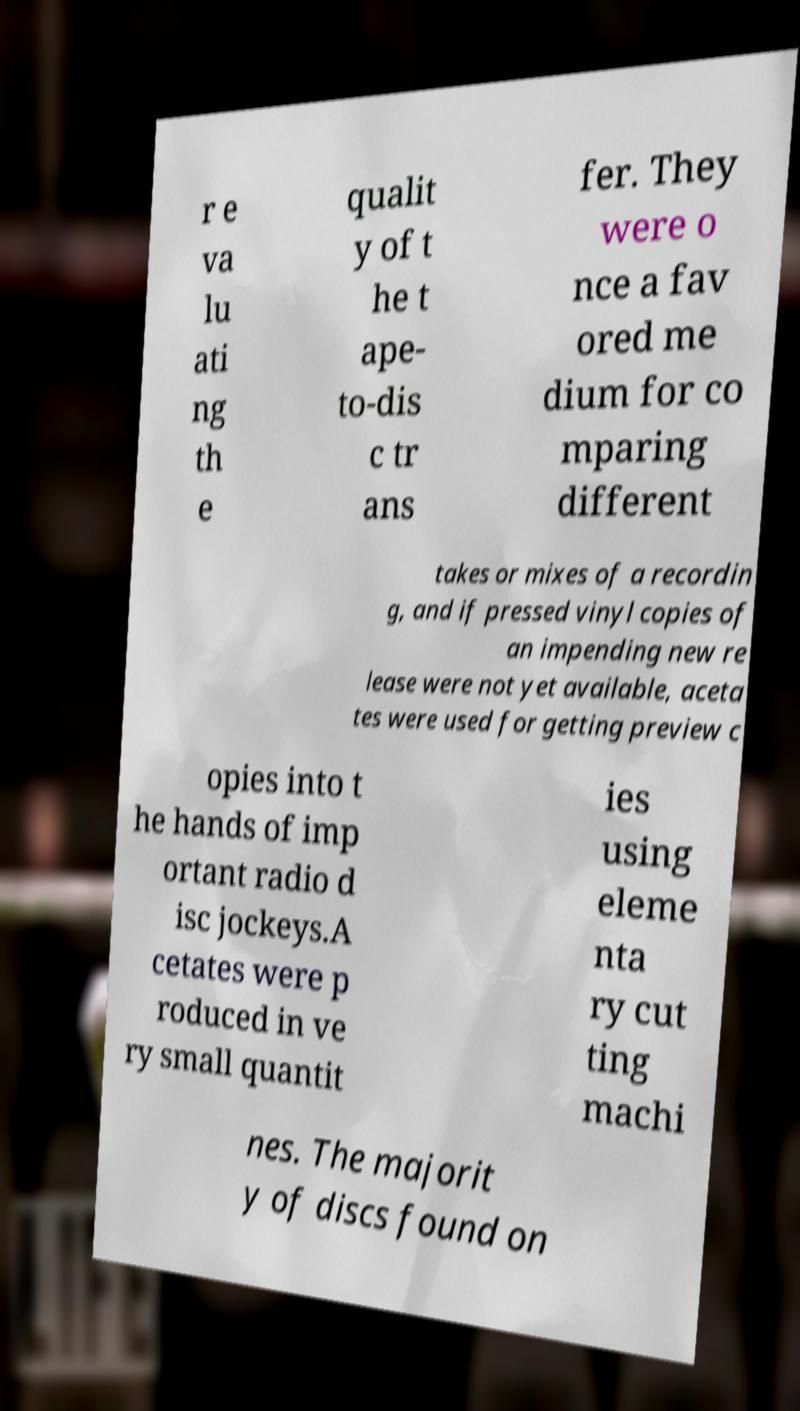Please read and relay the text visible in this image. What does it say? r e va lu ati ng th e qualit y of t he t ape- to-dis c tr ans fer. They were o nce a fav ored me dium for co mparing different takes or mixes of a recordin g, and if pressed vinyl copies of an impending new re lease were not yet available, aceta tes were used for getting preview c opies into t he hands of imp ortant radio d isc jockeys.A cetates were p roduced in ve ry small quantit ies using eleme nta ry cut ting machi nes. The majorit y of discs found on 